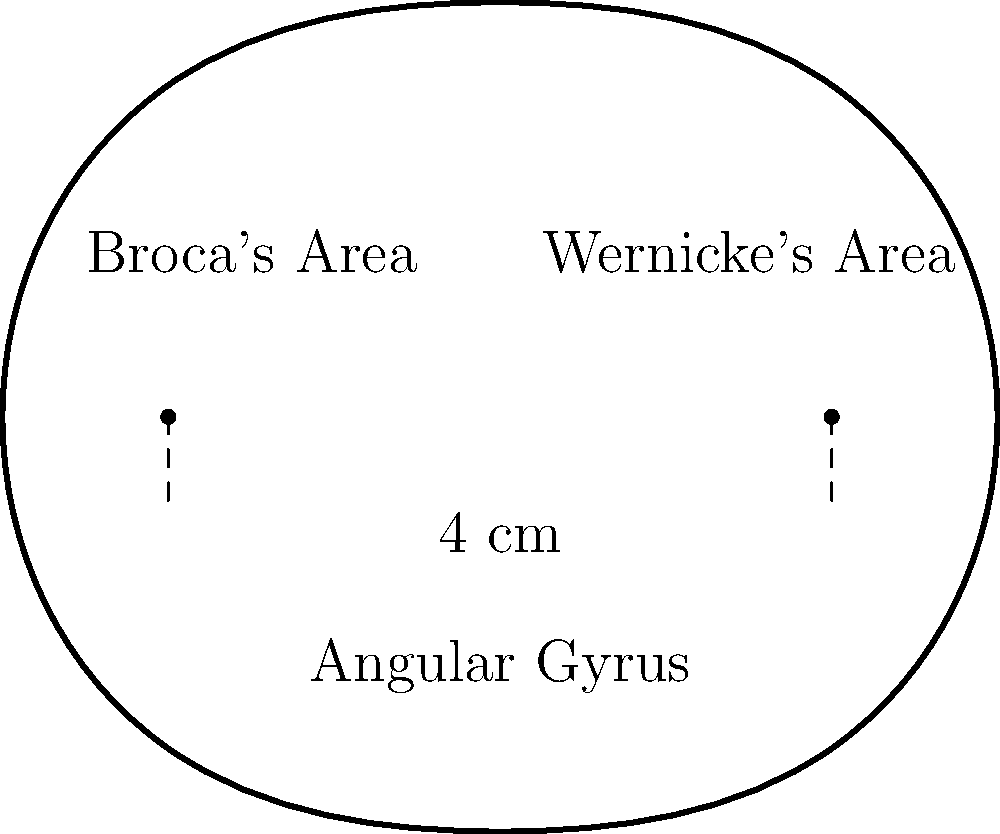A neurolinguistic study requires calculating the approximate area of a brain-shaped region containing key language centers. The region, when projected onto a 2D plane, resembles an ellipse with a width of 4 cm. Assuming the shape can be approximated as an ellipse with a height-to-width ratio of 5:4, determine the area of this linguistic region in square centimeters. Round your answer to two decimal places. To solve this problem, we'll follow these steps:

1) First, recall the formula for the area of an ellipse:
   $A = \pi ab$
   where $a$ and $b$ are the semi-major and semi-minor axes.

2) We're given the width of the ellipse, which is the full length of the minor axis:
   Width = 4 cm
   So, the semi-minor axis $b = 4/2 = 2$ cm

3) We're told the height-to-width ratio is 5:4. This means:
   Height : Width = 5 : 4
   Height = (5/4) * Width = (5/4) * 4 = 5 cm

4) The semi-major axis is half of this height:
   $a = 5/2 = 2.5$ cm

5) Now we can plug these values into our area formula:
   $A = \pi ab = \pi(2.5)(2) = 5\pi$ cm²

6) Calculate this value and round to two decimal places:
   $A = 5\pi \approx 15.71$ cm²
Answer: 15.71 cm² 